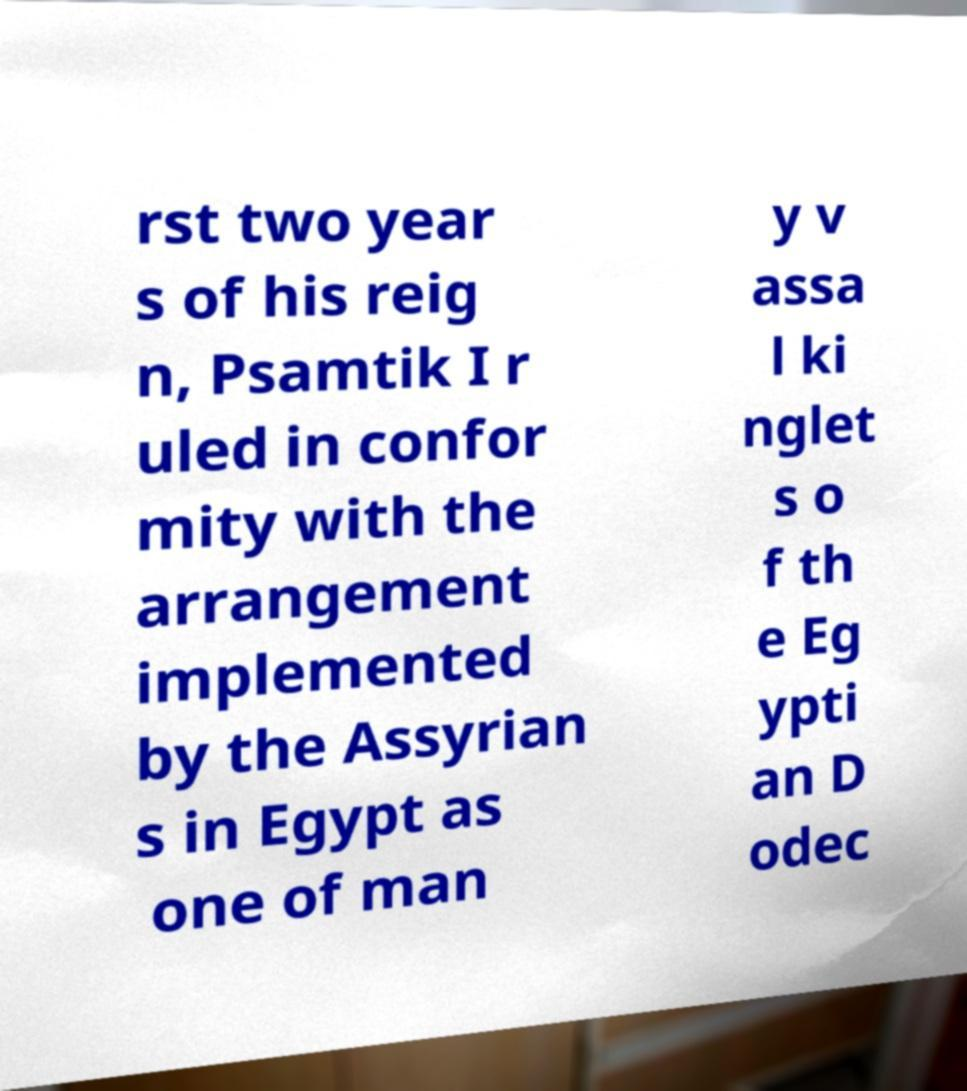Could you extract and type out the text from this image? rst two year s of his reig n, Psamtik I r uled in confor mity with the arrangement implemented by the Assyrian s in Egypt as one of man y v assa l ki nglet s o f th e Eg ypti an D odec 